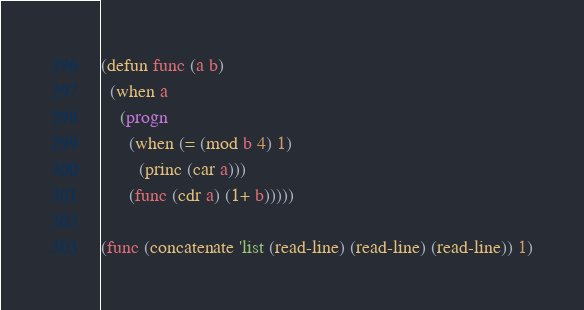<code> <loc_0><loc_0><loc_500><loc_500><_Lisp_>(defun func (a b)
  (when a
	(progn
	  (when (= (mod b 4) 1)
		(princ (car a)))
	  (func (cdr a) (1+ b)))))

(func (concatenate 'list (read-line) (read-line) (read-line)) 1)
</code> 